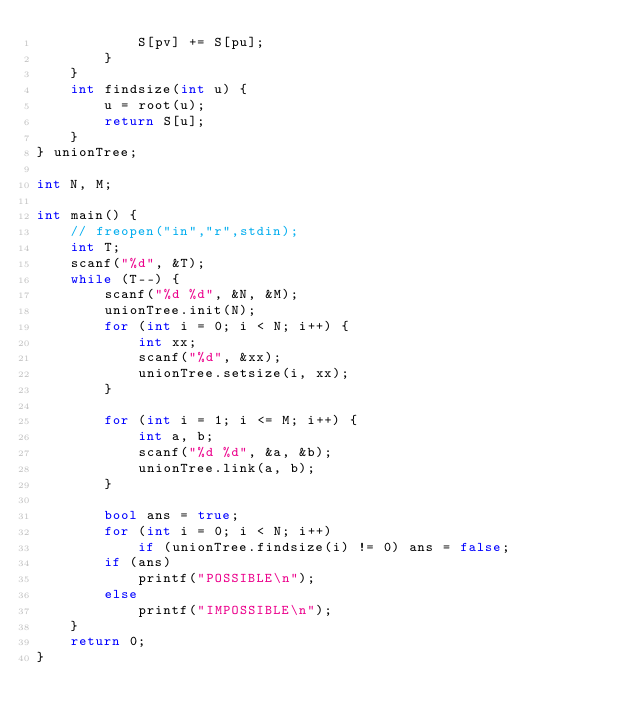<code> <loc_0><loc_0><loc_500><loc_500><_C++_>            S[pv] += S[pu];
        }
    }
    int findsize(int u) {
        u = root(u);
        return S[u];
    }
} unionTree;

int N, M;

int main() {
    // freopen("in","r",stdin);
    int T;
    scanf("%d", &T);
    while (T--) {
        scanf("%d %d", &N, &M);
        unionTree.init(N);
        for (int i = 0; i < N; i++) {
            int xx;
            scanf("%d", &xx);
            unionTree.setsize(i, xx);
        }

        for (int i = 1; i <= M; i++) {
            int a, b;
            scanf("%d %d", &a, &b);
            unionTree.link(a, b);
        }

        bool ans = true;
        for (int i = 0; i < N; i++)
            if (unionTree.findsize(i) != 0) ans = false;
        if (ans)
            printf("POSSIBLE\n");
        else
            printf("IMPOSSIBLE\n");
    }
    return 0;
}</code> 